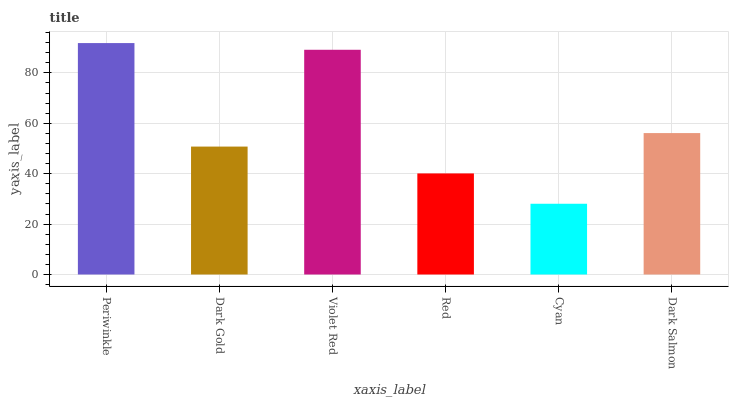Is Cyan the minimum?
Answer yes or no. Yes. Is Periwinkle the maximum?
Answer yes or no. Yes. Is Dark Gold the minimum?
Answer yes or no. No. Is Dark Gold the maximum?
Answer yes or no. No. Is Periwinkle greater than Dark Gold?
Answer yes or no. Yes. Is Dark Gold less than Periwinkle?
Answer yes or no. Yes. Is Dark Gold greater than Periwinkle?
Answer yes or no. No. Is Periwinkle less than Dark Gold?
Answer yes or no. No. Is Dark Salmon the high median?
Answer yes or no. Yes. Is Dark Gold the low median?
Answer yes or no. Yes. Is Violet Red the high median?
Answer yes or no. No. Is Red the low median?
Answer yes or no. No. 